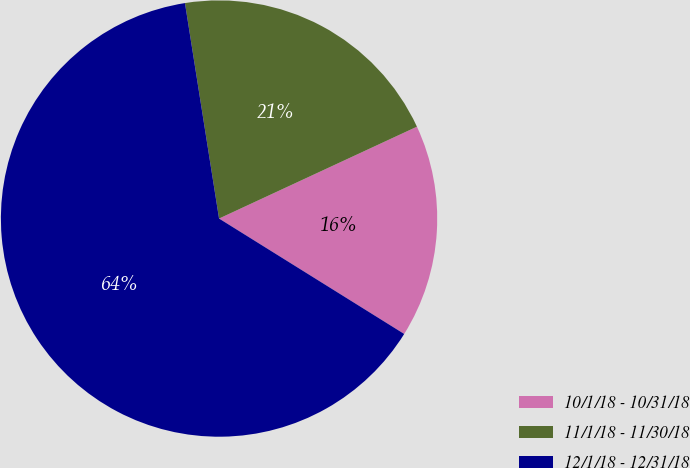Convert chart to OTSL. <chart><loc_0><loc_0><loc_500><loc_500><pie_chart><fcel>10/1/18 - 10/31/18<fcel>11/1/18 - 11/30/18<fcel>12/1/18 - 12/31/18<nl><fcel>15.79%<fcel>20.58%<fcel>63.63%<nl></chart> 